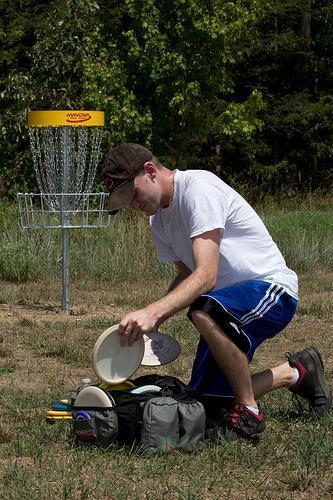How many people are in the photo?
Give a very brief answer. 1. How many discs are the man holding?
Give a very brief answer. 2. 